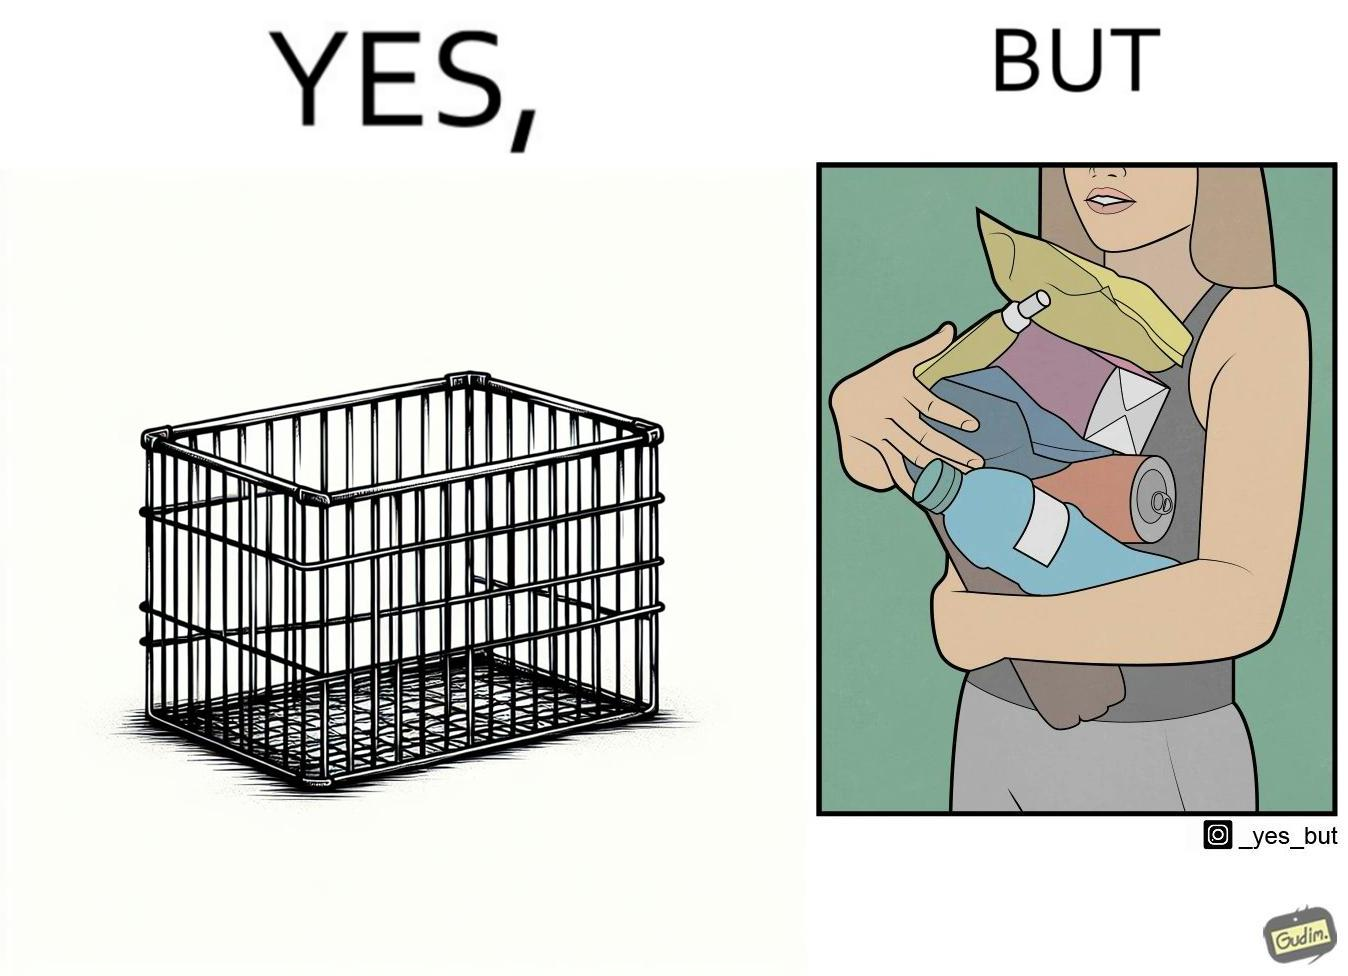Describe the contrast between the left and right parts of this image. In the left part of the image: a steel frame basket In the right part of the image: a woman carrying many objects at once trying to hold them, and protecting them from falling off 